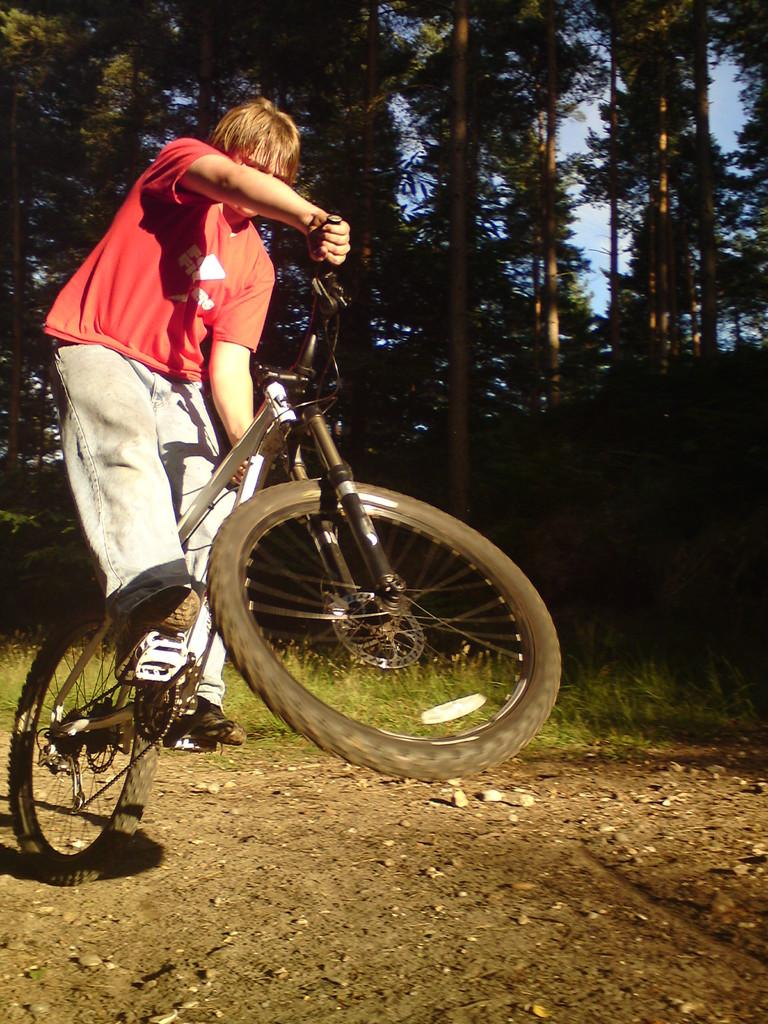What is the man in the image doing? The man is riding a bicycle in the image. What color is the t-shirt the man is wearing? The man is wearing a red t-shirt. What type of pants is the man wearing? The man is wearing trousers. What type of footwear is the man wearing? The man is wearing shoes. What can be seen in the background of the image? There are trees and grass in the background of the image. What is at the bottom of the image? There are stones and land at the bottom of the image. What type of harmony can be heard in the image? There is no audible sound in the image, so it is not possible to determine if any harmony can be heard. 